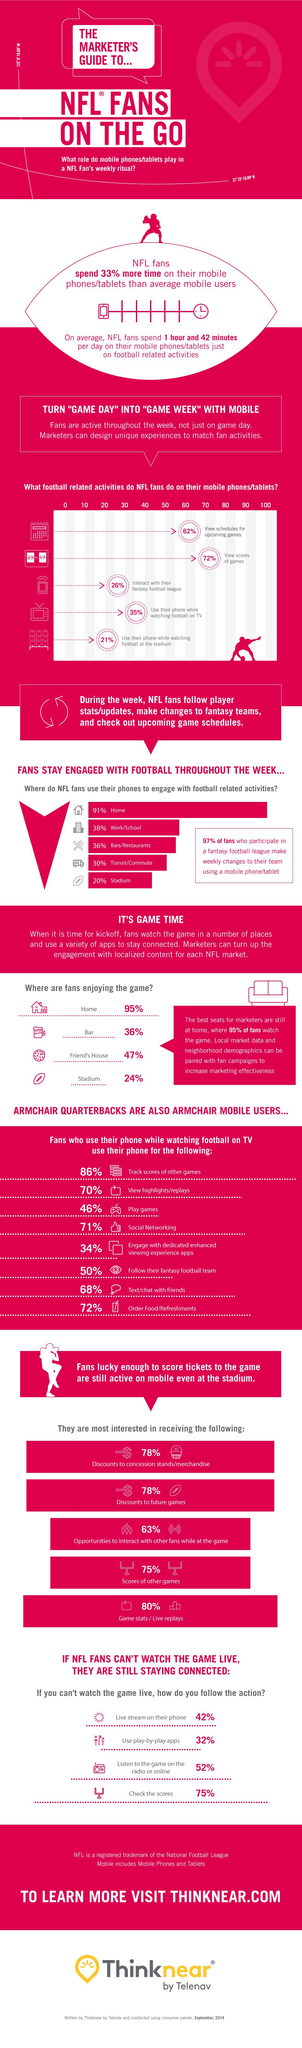List a handful of essential elements in this visual. According to a recent survey, a staggering 91% of NFL fans use their phones to engage with football-related activities throughout the week. The majority of NFL fans engage in football-related activities on their mobile phones and tablets, primarily viewing scores of games. According to a recent survey, 26% of NFL fans use their mobile phones or tablets to interact with their fantasy football league. The majority of NFL fans prefer to watch the game in the comfort of their own homes. According to a survey, 71% of NFL fans engage in social networking while watching football on TV. 